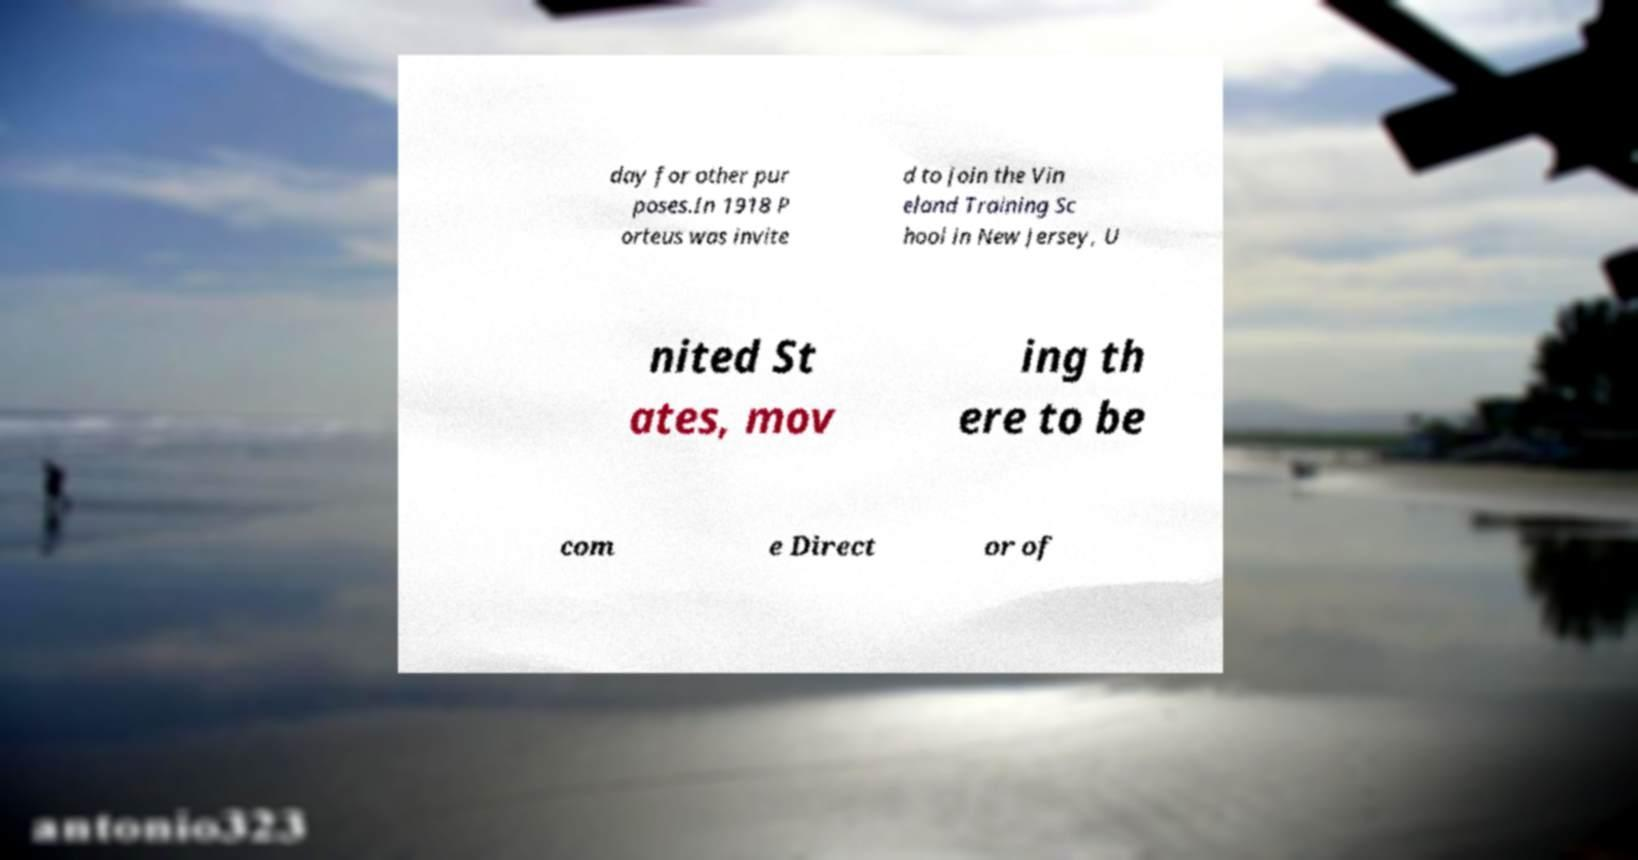Please identify and transcribe the text found in this image. day for other pur poses.In 1918 P orteus was invite d to join the Vin eland Training Sc hool in New Jersey, U nited St ates, mov ing th ere to be com e Direct or of 